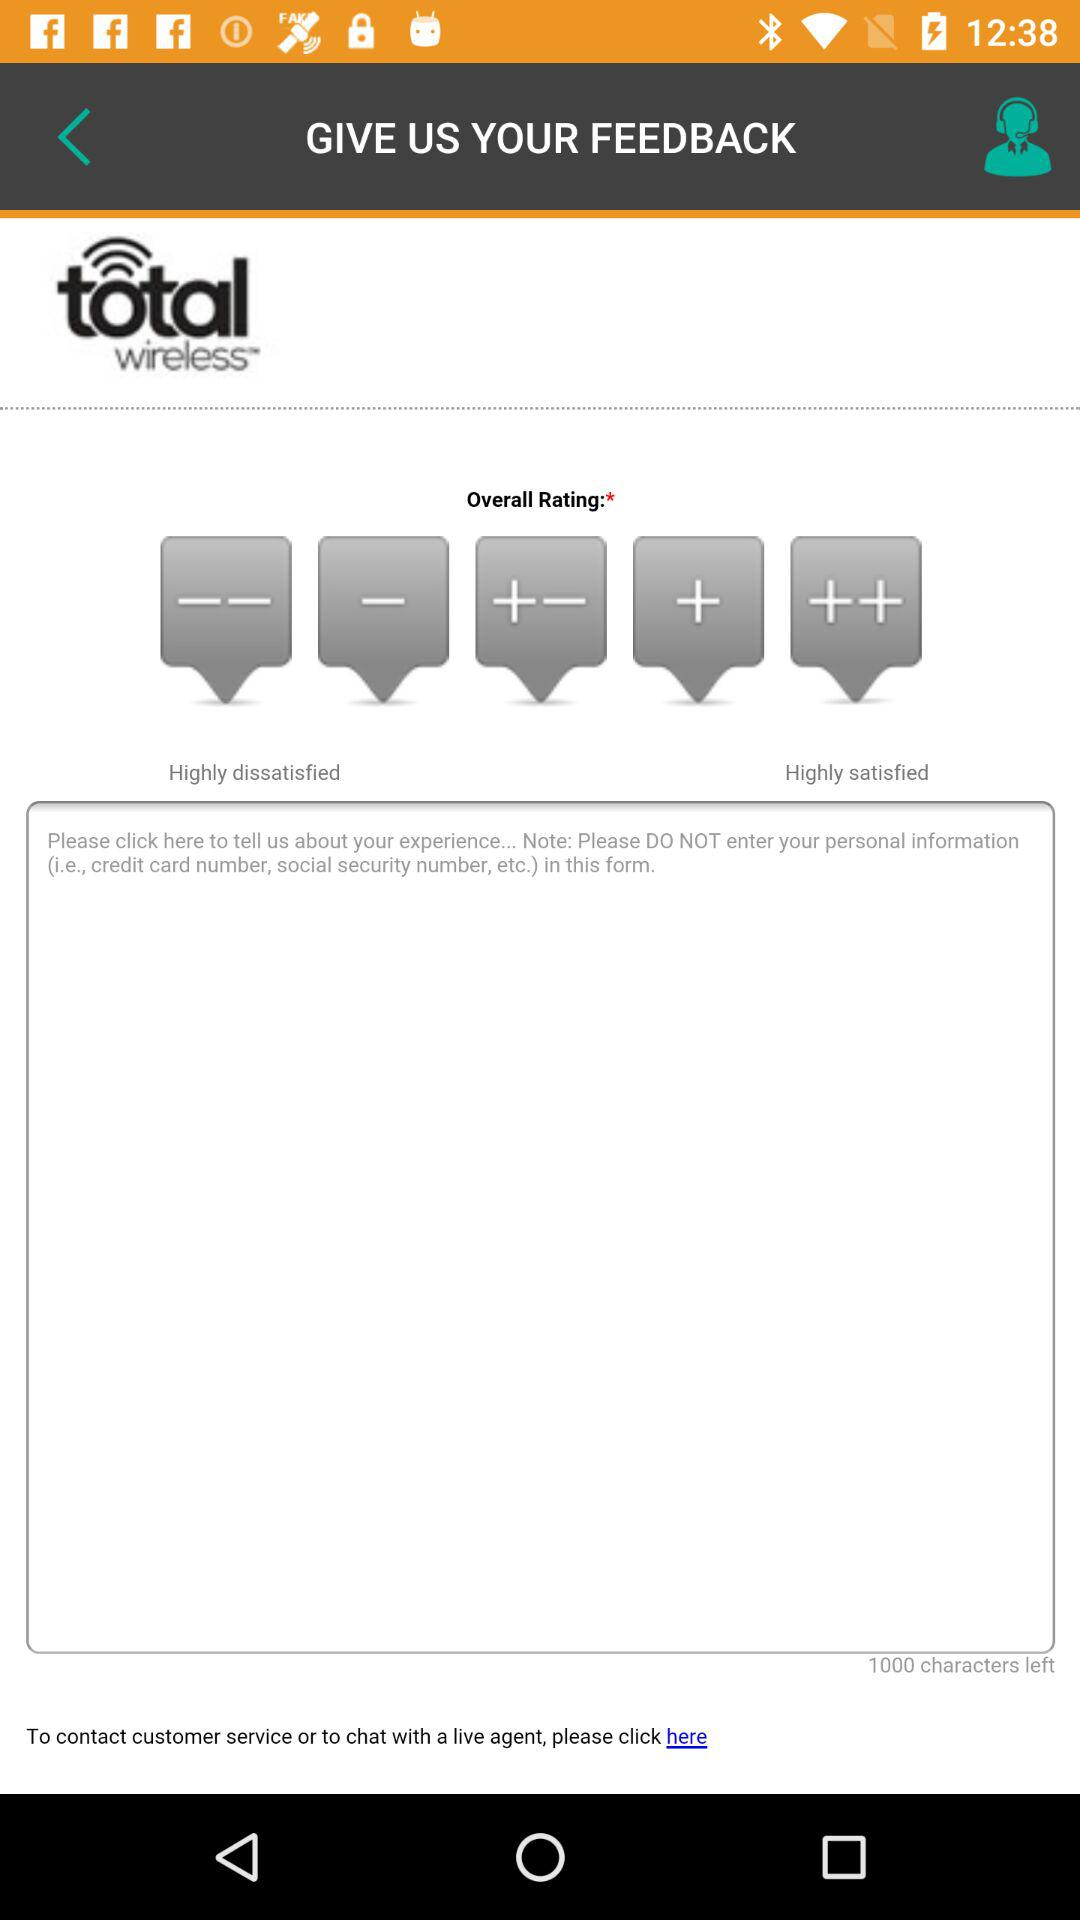How many options for rating are available?
Answer the question using a single word or phrase. 5 